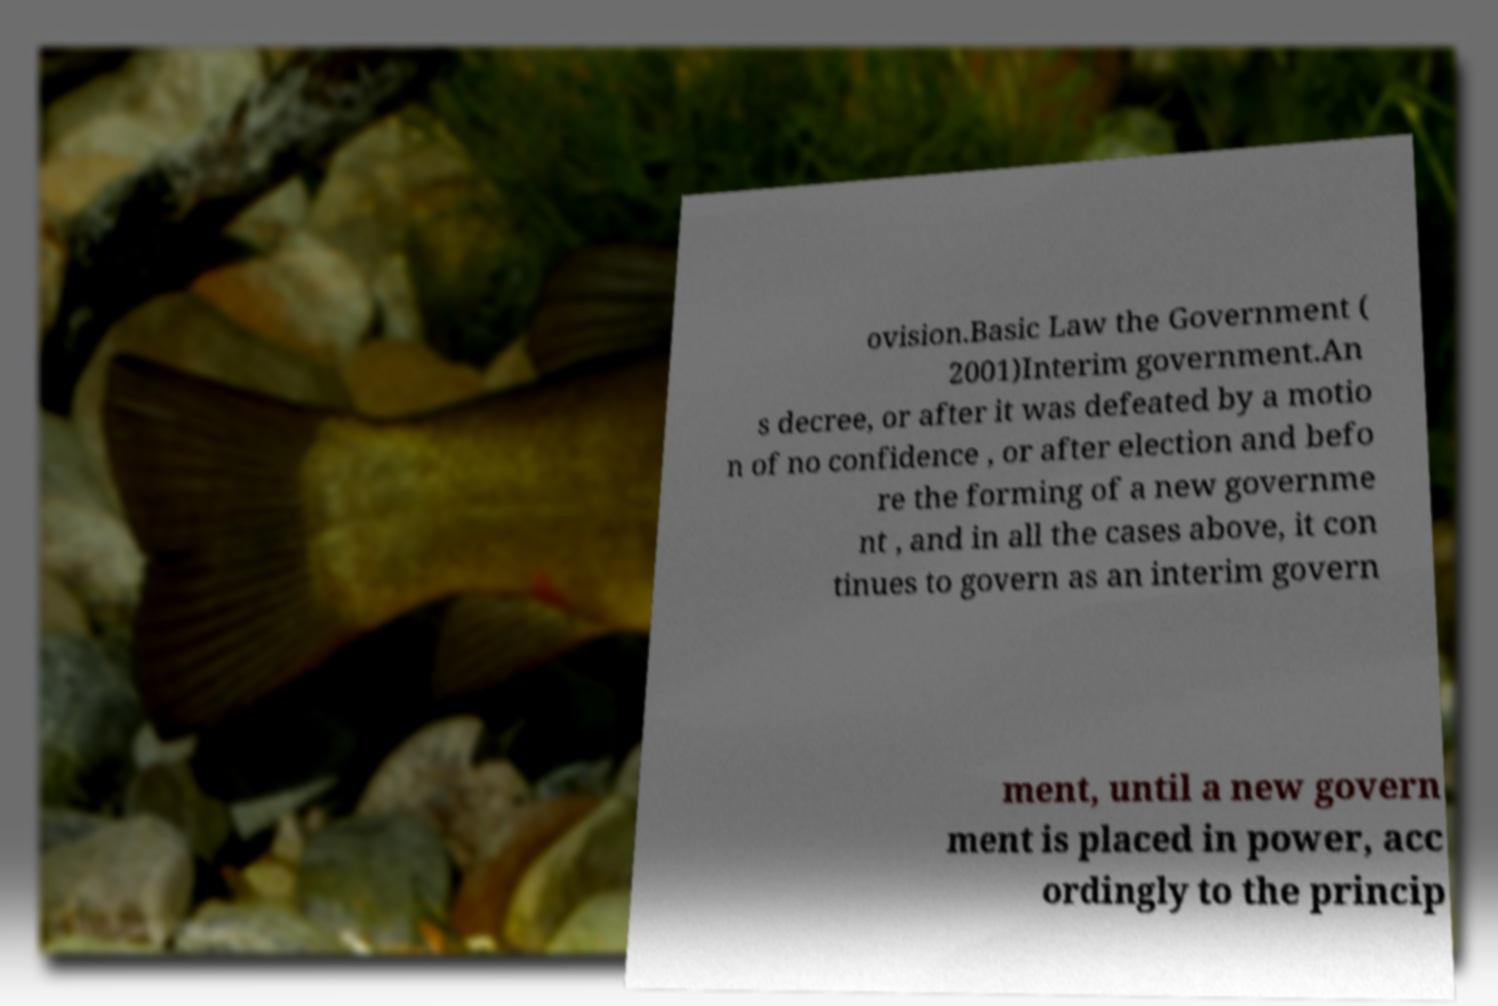Please read and relay the text visible in this image. What does it say? ovision.Basic Law the Government ( 2001)Interim government.An s decree, or after it was defeated by a motio n of no confidence , or after election and befo re the forming of a new governme nt , and in all the cases above, it con tinues to govern as an interim govern ment, until a new govern ment is placed in power, acc ordingly to the princip 